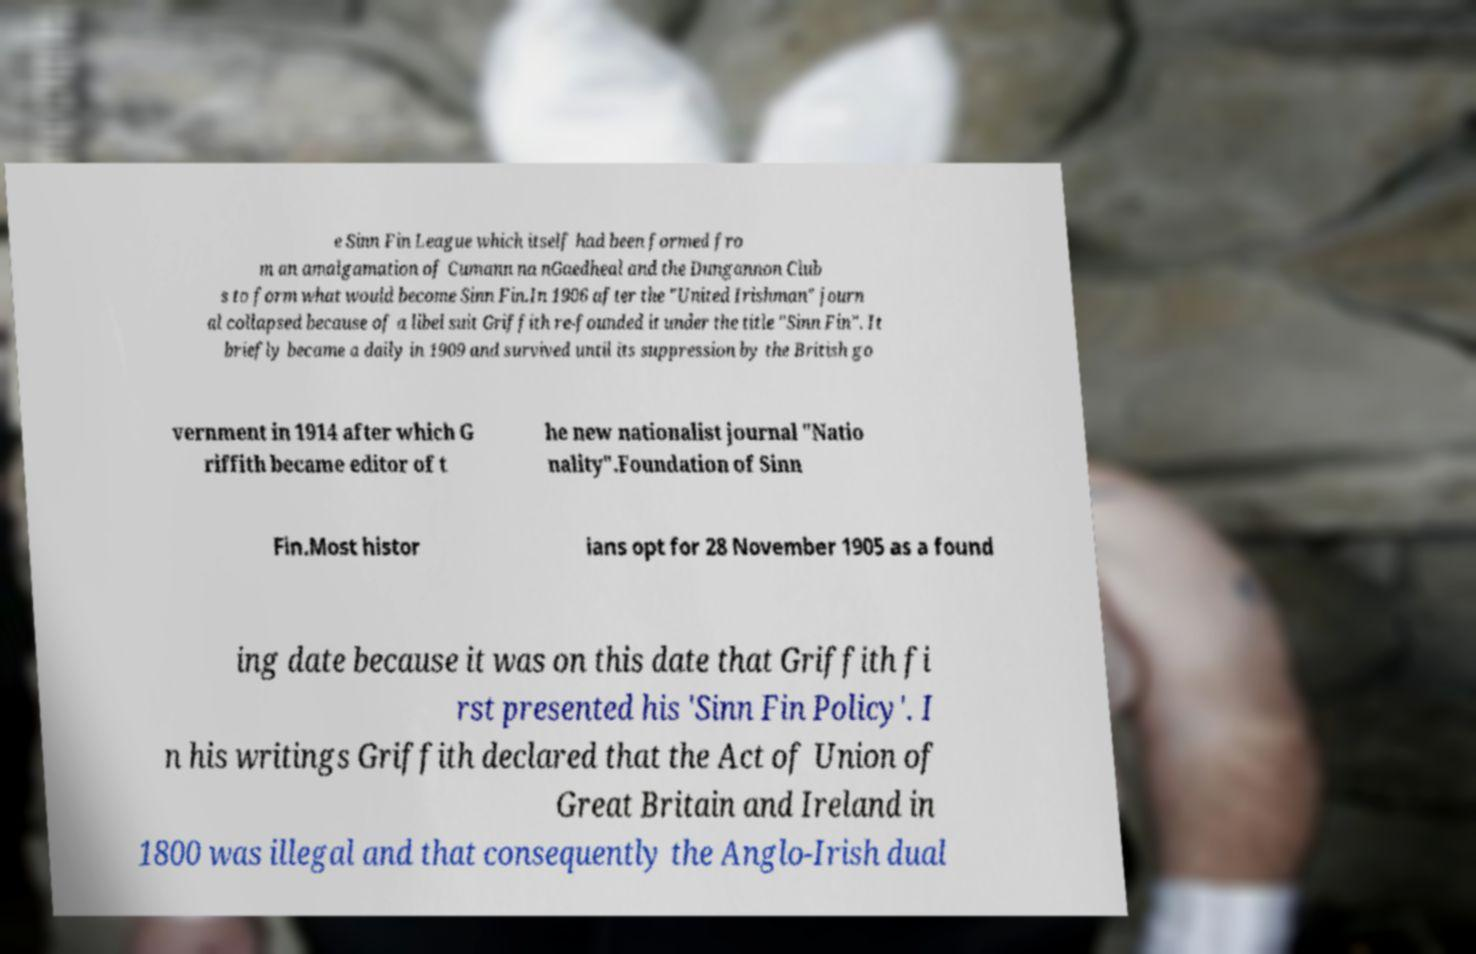For documentation purposes, I need the text within this image transcribed. Could you provide that? e Sinn Fin League which itself had been formed fro m an amalgamation of Cumann na nGaedheal and the Dungannon Club s to form what would become Sinn Fin.In 1906 after the "United Irishman" journ al collapsed because of a libel suit Griffith re-founded it under the title "Sinn Fin". It briefly became a daily in 1909 and survived until its suppression by the British go vernment in 1914 after which G riffith became editor of t he new nationalist journal "Natio nality".Foundation of Sinn Fin.Most histor ians opt for 28 November 1905 as a found ing date because it was on this date that Griffith fi rst presented his 'Sinn Fin Policy'. I n his writings Griffith declared that the Act of Union of Great Britain and Ireland in 1800 was illegal and that consequently the Anglo-Irish dual 